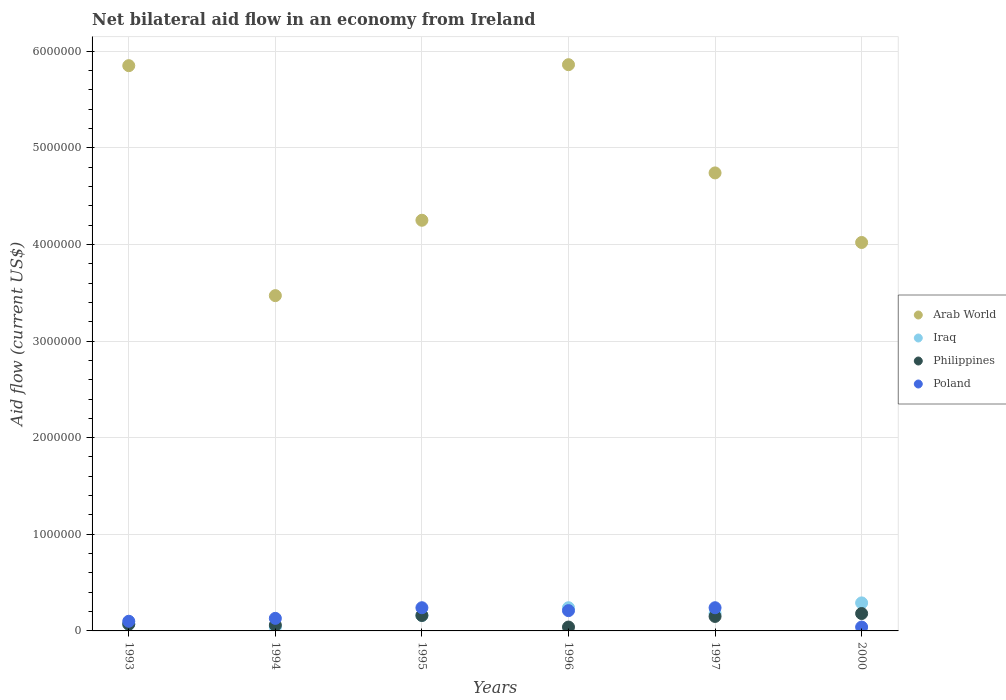Is the number of dotlines equal to the number of legend labels?
Make the answer very short. Yes. What is the net bilateral aid flow in Iraq in 1994?
Give a very brief answer. 4.00e+04. Across all years, what is the maximum net bilateral aid flow in Poland?
Make the answer very short. 2.40e+05. In which year was the net bilateral aid flow in Philippines maximum?
Offer a terse response. 2000. In which year was the net bilateral aid flow in Arab World minimum?
Ensure brevity in your answer.  1994. What is the total net bilateral aid flow in Poland in the graph?
Provide a succinct answer. 9.60e+05. What is the difference between the net bilateral aid flow in Poland in 1997 and that in 2000?
Your answer should be compact. 2.00e+05. What is the average net bilateral aid flow in Arab World per year?
Offer a very short reply. 4.70e+06. In the year 1995, what is the difference between the net bilateral aid flow in Arab World and net bilateral aid flow in Poland?
Your response must be concise. 4.01e+06. In how many years, is the net bilateral aid flow in Arab World greater than 1600000 US$?
Offer a terse response. 6. What is the ratio of the net bilateral aid flow in Poland in 1994 to that in 1996?
Offer a very short reply. 0.62. Is the difference between the net bilateral aid flow in Arab World in 1993 and 1996 greater than the difference between the net bilateral aid flow in Poland in 1993 and 1996?
Ensure brevity in your answer.  Yes. What is the difference between the highest and the lowest net bilateral aid flow in Arab World?
Give a very brief answer. 2.39e+06. Is the sum of the net bilateral aid flow in Philippines in 1993 and 1997 greater than the maximum net bilateral aid flow in Iraq across all years?
Offer a very short reply. No. Is it the case that in every year, the sum of the net bilateral aid flow in Iraq and net bilateral aid flow in Philippines  is greater than the sum of net bilateral aid flow in Poland and net bilateral aid flow in Arab World?
Your answer should be very brief. No. Is it the case that in every year, the sum of the net bilateral aid flow in Iraq and net bilateral aid flow in Poland  is greater than the net bilateral aid flow in Philippines?
Make the answer very short. Yes. Does the net bilateral aid flow in Philippines monotonically increase over the years?
Offer a very short reply. No. Is the net bilateral aid flow in Iraq strictly greater than the net bilateral aid flow in Poland over the years?
Provide a succinct answer. No. Is the net bilateral aid flow in Iraq strictly less than the net bilateral aid flow in Arab World over the years?
Keep it short and to the point. Yes. How many dotlines are there?
Ensure brevity in your answer.  4. What is the difference between two consecutive major ticks on the Y-axis?
Provide a succinct answer. 1.00e+06. Does the graph contain any zero values?
Ensure brevity in your answer.  No. How are the legend labels stacked?
Make the answer very short. Vertical. What is the title of the graph?
Your response must be concise. Net bilateral aid flow in an economy from Ireland. Does "Uganda" appear as one of the legend labels in the graph?
Ensure brevity in your answer.  No. What is the label or title of the X-axis?
Provide a short and direct response. Years. What is the Aid flow (current US$) in Arab World in 1993?
Your response must be concise. 5.85e+06. What is the Aid flow (current US$) of Poland in 1993?
Ensure brevity in your answer.  1.00e+05. What is the Aid flow (current US$) in Arab World in 1994?
Your response must be concise. 3.47e+06. What is the Aid flow (current US$) of Iraq in 1994?
Give a very brief answer. 4.00e+04. What is the Aid flow (current US$) in Philippines in 1994?
Ensure brevity in your answer.  6.00e+04. What is the Aid flow (current US$) in Poland in 1994?
Ensure brevity in your answer.  1.30e+05. What is the Aid flow (current US$) of Arab World in 1995?
Your response must be concise. 4.25e+06. What is the Aid flow (current US$) of Poland in 1995?
Your answer should be very brief. 2.40e+05. What is the Aid flow (current US$) of Arab World in 1996?
Give a very brief answer. 5.86e+06. What is the Aid flow (current US$) of Iraq in 1996?
Make the answer very short. 2.40e+05. What is the Aid flow (current US$) of Philippines in 1996?
Provide a short and direct response. 4.00e+04. What is the Aid flow (current US$) of Arab World in 1997?
Your answer should be compact. 4.74e+06. What is the Aid flow (current US$) of Iraq in 1997?
Provide a short and direct response. 1.80e+05. What is the Aid flow (current US$) in Philippines in 1997?
Provide a short and direct response. 1.50e+05. What is the Aid flow (current US$) of Arab World in 2000?
Give a very brief answer. 4.02e+06. What is the Aid flow (current US$) in Philippines in 2000?
Provide a short and direct response. 1.80e+05. What is the Aid flow (current US$) of Poland in 2000?
Keep it short and to the point. 4.00e+04. Across all years, what is the maximum Aid flow (current US$) in Arab World?
Give a very brief answer. 5.86e+06. Across all years, what is the maximum Aid flow (current US$) of Poland?
Your answer should be compact. 2.40e+05. Across all years, what is the minimum Aid flow (current US$) in Arab World?
Your response must be concise. 3.47e+06. Across all years, what is the minimum Aid flow (current US$) of Iraq?
Provide a succinct answer. 4.00e+04. Across all years, what is the minimum Aid flow (current US$) in Philippines?
Give a very brief answer. 4.00e+04. Across all years, what is the minimum Aid flow (current US$) of Poland?
Your response must be concise. 4.00e+04. What is the total Aid flow (current US$) of Arab World in the graph?
Provide a succinct answer. 2.82e+07. What is the total Aid flow (current US$) in Iraq in the graph?
Offer a terse response. 9.80e+05. What is the total Aid flow (current US$) of Poland in the graph?
Offer a very short reply. 9.60e+05. What is the difference between the Aid flow (current US$) of Arab World in 1993 and that in 1994?
Offer a terse response. 2.38e+06. What is the difference between the Aid flow (current US$) of Iraq in 1993 and that in 1994?
Provide a short and direct response. 3.00e+04. What is the difference between the Aid flow (current US$) of Arab World in 1993 and that in 1995?
Give a very brief answer. 1.60e+06. What is the difference between the Aid flow (current US$) in Poland in 1993 and that in 1995?
Your answer should be compact. -1.40e+05. What is the difference between the Aid flow (current US$) of Philippines in 1993 and that in 1996?
Give a very brief answer. 3.00e+04. What is the difference between the Aid flow (current US$) of Poland in 1993 and that in 1996?
Keep it short and to the point. -1.10e+05. What is the difference between the Aid flow (current US$) of Arab World in 1993 and that in 1997?
Give a very brief answer. 1.11e+06. What is the difference between the Aid flow (current US$) in Iraq in 1993 and that in 1997?
Provide a succinct answer. -1.10e+05. What is the difference between the Aid flow (current US$) in Philippines in 1993 and that in 1997?
Your answer should be compact. -8.00e+04. What is the difference between the Aid flow (current US$) in Arab World in 1993 and that in 2000?
Ensure brevity in your answer.  1.83e+06. What is the difference between the Aid flow (current US$) in Iraq in 1993 and that in 2000?
Your answer should be compact. -2.20e+05. What is the difference between the Aid flow (current US$) of Philippines in 1993 and that in 2000?
Provide a succinct answer. -1.10e+05. What is the difference between the Aid flow (current US$) of Poland in 1993 and that in 2000?
Offer a very short reply. 6.00e+04. What is the difference between the Aid flow (current US$) of Arab World in 1994 and that in 1995?
Offer a terse response. -7.80e+05. What is the difference between the Aid flow (current US$) of Iraq in 1994 and that in 1995?
Give a very brief answer. -1.20e+05. What is the difference between the Aid flow (current US$) of Poland in 1994 and that in 1995?
Offer a terse response. -1.10e+05. What is the difference between the Aid flow (current US$) of Arab World in 1994 and that in 1996?
Offer a very short reply. -2.39e+06. What is the difference between the Aid flow (current US$) in Iraq in 1994 and that in 1996?
Provide a succinct answer. -2.00e+05. What is the difference between the Aid flow (current US$) in Philippines in 1994 and that in 1996?
Give a very brief answer. 2.00e+04. What is the difference between the Aid flow (current US$) of Arab World in 1994 and that in 1997?
Offer a terse response. -1.27e+06. What is the difference between the Aid flow (current US$) in Philippines in 1994 and that in 1997?
Keep it short and to the point. -9.00e+04. What is the difference between the Aid flow (current US$) of Arab World in 1994 and that in 2000?
Your response must be concise. -5.50e+05. What is the difference between the Aid flow (current US$) of Iraq in 1994 and that in 2000?
Make the answer very short. -2.50e+05. What is the difference between the Aid flow (current US$) in Philippines in 1994 and that in 2000?
Your answer should be compact. -1.20e+05. What is the difference between the Aid flow (current US$) in Poland in 1994 and that in 2000?
Your answer should be very brief. 9.00e+04. What is the difference between the Aid flow (current US$) of Arab World in 1995 and that in 1996?
Keep it short and to the point. -1.61e+06. What is the difference between the Aid flow (current US$) of Philippines in 1995 and that in 1996?
Your response must be concise. 1.20e+05. What is the difference between the Aid flow (current US$) of Arab World in 1995 and that in 1997?
Your answer should be compact. -4.90e+05. What is the difference between the Aid flow (current US$) in Iraq in 1995 and that in 1997?
Offer a very short reply. -2.00e+04. What is the difference between the Aid flow (current US$) in Poland in 1995 and that in 1997?
Provide a succinct answer. 0. What is the difference between the Aid flow (current US$) of Arab World in 1995 and that in 2000?
Offer a very short reply. 2.30e+05. What is the difference between the Aid flow (current US$) of Philippines in 1995 and that in 2000?
Your answer should be compact. -2.00e+04. What is the difference between the Aid flow (current US$) of Arab World in 1996 and that in 1997?
Offer a terse response. 1.12e+06. What is the difference between the Aid flow (current US$) in Iraq in 1996 and that in 1997?
Offer a terse response. 6.00e+04. What is the difference between the Aid flow (current US$) in Philippines in 1996 and that in 1997?
Offer a very short reply. -1.10e+05. What is the difference between the Aid flow (current US$) in Poland in 1996 and that in 1997?
Provide a succinct answer. -3.00e+04. What is the difference between the Aid flow (current US$) of Arab World in 1996 and that in 2000?
Provide a short and direct response. 1.84e+06. What is the difference between the Aid flow (current US$) in Arab World in 1997 and that in 2000?
Keep it short and to the point. 7.20e+05. What is the difference between the Aid flow (current US$) of Iraq in 1997 and that in 2000?
Your response must be concise. -1.10e+05. What is the difference between the Aid flow (current US$) in Poland in 1997 and that in 2000?
Offer a terse response. 2.00e+05. What is the difference between the Aid flow (current US$) of Arab World in 1993 and the Aid flow (current US$) of Iraq in 1994?
Make the answer very short. 5.81e+06. What is the difference between the Aid flow (current US$) in Arab World in 1993 and the Aid flow (current US$) in Philippines in 1994?
Keep it short and to the point. 5.79e+06. What is the difference between the Aid flow (current US$) in Arab World in 1993 and the Aid flow (current US$) in Poland in 1994?
Make the answer very short. 5.72e+06. What is the difference between the Aid flow (current US$) in Iraq in 1993 and the Aid flow (current US$) in Philippines in 1994?
Offer a very short reply. 10000. What is the difference between the Aid flow (current US$) in Arab World in 1993 and the Aid flow (current US$) in Iraq in 1995?
Your answer should be very brief. 5.69e+06. What is the difference between the Aid flow (current US$) in Arab World in 1993 and the Aid flow (current US$) in Philippines in 1995?
Give a very brief answer. 5.69e+06. What is the difference between the Aid flow (current US$) of Arab World in 1993 and the Aid flow (current US$) of Poland in 1995?
Keep it short and to the point. 5.61e+06. What is the difference between the Aid flow (current US$) in Iraq in 1993 and the Aid flow (current US$) in Philippines in 1995?
Make the answer very short. -9.00e+04. What is the difference between the Aid flow (current US$) of Iraq in 1993 and the Aid flow (current US$) of Poland in 1995?
Make the answer very short. -1.70e+05. What is the difference between the Aid flow (current US$) of Philippines in 1993 and the Aid flow (current US$) of Poland in 1995?
Provide a succinct answer. -1.70e+05. What is the difference between the Aid flow (current US$) in Arab World in 1993 and the Aid flow (current US$) in Iraq in 1996?
Provide a short and direct response. 5.61e+06. What is the difference between the Aid flow (current US$) of Arab World in 1993 and the Aid flow (current US$) of Philippines in 1996?
Your response must be concise. 5.81e+06. What is the difference between the Aid flow (current US$) of Arab World in 1993 and the Aid flow (current US$) of Poland in 1996?
Offer a very short reply. 5.64e+06. What is the difference between the Aid flow (current US$) of Iraq in 1993 and the Aid flow (current US$) of Poland in 1996?
Provide a short and direct response. -1.40e+05. What is the difference between the Aid flow (current US$) of Philippines in 1993 and the Aid flow (current US$) of Poland in 1996?
Your response must be concise. -1.40e+05. What is the difference between the Aid flow (current US$) in Arab World in 1993 and the Aid flow (current US$) in Iraq in 1997?
Ensure brevity in your answer.  5.67e+06. What is the difference between the Aid flow (current US$) of Arab World in 1993 and the Aid flow (current US$) of Philippines in 1997?
Your answer should be very brief. 5.70e+06. What is the difference between the Aid flow (current US$) in Arab World in 1993 and the Aid flow (current US$) in Poland in 1997?
Your answer should be very brief. 5.61e+06. What is the difference between the Aid flow (current US$) in Iraq in 1993 and the Aid flow (current US$) in Philippines in 1997?
Ensure brevity in your answer.  -8.00e+04. What is the difference between the Aid flow (current US$) in Philippines in 1993 and the Aid flow (current US$) in Poland in 1997?
Your response must be concise. -1.70e+05. What is the difference between the Aid flow (current US$) of Arab World in 1993 and the Aid flow (current US$) of Iraq in 2000?
Provide a succinct answer. 5.56e+06. What is the difference between the Aid flow (current US$) in Arab World in 1993 and the Aid flow (current US$) in Philippines in 2000?
Offer a terse response. 5.67e+06. What is the difference between the Aid flow (current US$) in Arab World in 1993 and the Aid flow (current US$) in Poland in 2000?
Your answer should be compact. 5.81e+06. What is the difference between the Aid flow (current US$) of Philippines in 1993 and the Aid flow (current US$) of Poland in 2000?
Make the answer very short. 3.00e+04. What is the difference between the Aid flow (current US$) of Arab World in 1994 and the Aid flow (current US$) of Iraq in 1995?
Give a very brief answer. 3.31e+06. What is the difference between the Aid flow (current US$) in Arab World in 1994 and the Aid flow (current US$) in Philippines in 1995?
Your answer should be very brief. 3.31e+06. What is the difference between the Aid flow (current US$) of Arab World in 1994 and the Aid flow (current US$) of Poland in 1995?
Keep it short and to the point. 3.23e+06. What is the difference between the Aid flow (current US$) in Iraq in 1994 and the Aid flow (current US$) in Philippines in 1995?
Keep it short and to the point. -1.20e+05. What is the difference between the Aid flow (current US$) of Iraq in 1994 and the Aid flow (current US$) of Poland in 1995?
Ensure brevity in your answer.  -2.00e+05. What is the difference between the Aid flow (current US$) of Philippines in 1994 and the Aid flow (current US$) of Poland in 1995?
Keep it short and to the point. -1.80e+05. What is the difference between the Aid flow (current US$) in Arab World in 1994 and the Aid flow (current US$) in Iraq in 1996?
Give a very brief answer. 3.23e+06. What is the difference between the Aid flow (current US$) in Arab World in 1994 and the Aid flow (current US$) in Philippines in 1996?
Ensure brevity in your answer.  3.43e+06. What is the difference between the Aid flow (current US$) of Arab World in 1994 and the Aid flow (current US$) of Poland in 1996?
Offer a terse response. 3.26e+06. What is the difference between the Aid flow (current US$) in Arab World in 1994 and the Aid flow (current US$) in Iraq in 1997?
Provide a succinct answer. 3.29e+06. What is the difference between the Aid flow (current US$) in Arab World in 1994 and the Aid flow (current US$) in Philippines in 1997?
Your answer should be very brief. 3.32e+06. What is the difference between the Aid flow (current US$) of Arab World in 1994 and the Aid flow (current US$) of Poland in 1997?
Provide a succinct answer. 3.23e+06. What is the difference between the Aid flow (current US$) of Iraq in 1994 and the Aid flow (current US$) of Poland in 1997?
Ensure brevity in your answer.  -2.00e+05. What is the difference between the Aid flow (current US$) of Philippines in 1994 and the Aid flow (current US$) of Poland in 1997?
Keep it short and to the point. -1.80e+05. What is the difference between the Aid flow (current US$) of Arab World in 1994 and the Aid flow (current US$) of Iraq in 2000?
Your response must be concise. 3.18e+06. What is the difference between the Aid flow (current US$) in Arab World in 1994 and the Aid flow (current US$) in Philippines in 2000?
Keep it short and to the point. 3.29e+06. What is the difference between the Aid flow (current US$) of Arab World in 1994 and the Aid flow (current US$) of Poland in 2000?
Your answer should be compact. 3.43e+06. What is the difference between the Aid flow (current US$) in Iraq in 1994 and the Aid flow (current US$) in Poland in 2000?
Your answer should be compact. 0. What is the difference between the Aid flow (current US$) in Philippines in 1994 and the Aid flow (current US$) in Poland in 2000?
Your answer should be very brief. 2.00e+04. What is the difference between the Aid flow (current US$) in Arab World in 1995 and the Aid flow (current US$) in Iraq in 1996?
Keep it short and to the point. 4.01e+06. What is the difference between the Aid flow (current US$) of Arab World in 1995 and the Aid flow (current US$) of Philippines in 1996?
Offer a terse response. 4.21e+06. What is the difference between the Aid flow (current US$) of Arab World in 1995 and the Aid flow (current US$) of Poland in 1996?
Your response must be concise. 4.04e+06. What is the difference between the Aid flow (current US$) of Iraq in 1995 and the Aid flow (current US$) of Philippines in 1996?
Keep it short and to the point. 1.20e+05. What is the difference between the Aid flow (current US$) in Iraq in 1995 and the Aid flow (current US$) in Poland in 1996?
Ensure brevity in your answer.  -5.00e+04. What is the difference between the Aid flow (current US$) in Arab World in 1995 and the Aid flow (current US$) in Iraq in 1997?
Provide a short and direct response. 4.07e+06. What is the difference between the Aid flow (current US$) of Arab World in 1995 and the Aid flow (current US$) of Philippines in 1997?
Keep it short and to the point. 4.10e+06. What is the difference between the Aid flow (current US$) in Arab World in 1995 and the Aid flow (current US$) in Poland in 1997?
Your answer should be compact. 4.01e+06. What is the difference between the Aid flow (current US$) of Iraq in 1995 and the Aid flow (current US$) of Philippines in 1997?
Your response must be concise. 10000. What is the difference between the Aid flow (current US$) in Iraq in 1995 and the Aid flow (current US$) in Poland in 1997?
Offer a very short reply. -8.00e+04. What is the difference between the Aid flow (current US$) in Arab World in 1995 and the Aid flow (current US$) in Iraq in 2000?
Ensure brevity in your answer.  3.96e+06. What is the difference between the Aid flow (current US$) in Arab World in 1995 and the Aid flow (current US$) in Philippines in 2000?
Your answer should be very brief. 4.07e+06. What is the difference between the Aid flow (current US$) in Arab World in 1995 and the Aid flow (current US$) in Poland in 2000?
Offer a very short reply. 4.21e+06. What is the difference between the Aid flow (current US$) of Iraq in 1995 and the Aid flow (current US$) of Philippines in 2000?
Ensure brevity in your answer.  -2.00e+04. What is the difference between the Aid flow (current US$) of Iraq in 1995 and the Aid flow (current US$) of Poland in 2000?
Provide a short and direct response. 1.20e+05. What is the difference between the Aid flow (current US$) in Philippines in 1995 and the Aid flow (current US$) in Poland in 2000?
Ensure brevity in your answer.  1.20e+05. What is the difference between the Aid flow (current US$) of Arab World in 1996 and the Aid flow (current US$) of Iraq in 1997?
Keep it short and to the point. 5.68e+06. What is the difference between the Aid flow (current US$) in Arab World in 1996 and the Aid flow (current US$) in Philippines in 1997?
Your answer should be very brief. 5.71e+06. What is the difference between the Aid flow (current US$) in Arab World in 1996 and the Aid flow (current US$) in Poland in 1997?
Give a very brief answer. 5.62e+06. What is the difference between the Aid flow (current US$) in Iraq in 1996 and the Aid flow (current US$) in Philippines in 1997?
Offer a terse response. 9.00e+04. What is the difference between the Aid flow (current US$) in Arab World in 1996 and the Aid flow (current US$) in Iraq in 2000?
Your answer should be very brief. 5.57e+06. What is the difference between the Aid flow (current US$) of Arab World in 1996 and the Aid flow (current US$) of Philippines in 2000?
Your response must be concise. 5.68e+06. What is the difference between the Aid flow (current US$) of Arab World in 1996 and the Aid flow (current US$) of Poland in 2000?
Offer a terse response. 5.82e+06. What is the difference between the Aid flow (current US$) of Iraq in 1996 and the Aid flow (current US$) of Philippines in 2000?
Your response must be concise. 6.00e+04. What is the difference between the Aid flow (current US$) in Arab World in 1997 and the Aid flow (current US$) in Iraq in 2000?
Your answer should be compact. 4.45e+06. What is the difference between the Aid flow (current US$) of Arab World in 1997 and the Aid flow (current US$) of Philippines in 2000?
Keep it short and to the point. 4.56e+06. What is the difference between the Aid flow (current US$) in Arab World in 1997 and the Aid flow (current US$) in Poland in 2000?
Keep it short and to the point. 4.70e+06. What is the difference between the Aid flow (current US$) of Iraq in 1997 and the Aid flow (current US$) of Poland in 2000?
Your answer should be very brief. 1.40e+05. What is the difference between the Aid flow (current US$) of Philippines in 1997 and the Aid flow (current US$) of Poland in 2000?
Your response must be concise. 1.10e+05. What is the average Aid flow (current US$) of Arab World per year?
Your response must be concise. 4.70e+06. What is the average Aid flow (current US$) of Iraq per year?
Your response must be concise. 1.63e+05. What is the average Aid flow (current US$) in Philippines per year?
Ensure brevity in your answer.  1.10e+05. In the year 1993, what is the difference between the Aid flow (current US$) of Arab World and Aid flow (current US$) of Iraq?
Your response must be concise. 5.78e+06. In the year 1993, what is the difference between the Aid flow (current US$) of Arab World and Aid flow (current US$) of Philippines?
Ensure brevity in your answer.  5.78e+06. In the year 1993, what is the difference between the Aid flow (current US$) in Arab World and Aid flow (current US$) in Poland?
Give a very brief answer. 5.75e+06. In the year 1993, what is the difference between the Aid flow (current US$) in Iraq and Aid flow (current US$) in Philippines?
Offer a very short reply. 0. In the year 1993, what is the difference between the Aid flow (current US$) in Iraq and Aid flow (current US$) in Poland?
Ensure brevity in your answer.  -3.00e+04. In the year 1994, what is the difference between the Aid flow (current US$) in Arab World and Aid flow (current US$) in Iraq?
Your answer should be very brief. 3.43e+06. In the year 1994, what is the difference between the Aid flow (current US$) in Arab World and Aid flow (current US$) in Philippines?
Offer a terse response. 3.41e+06. In the year 1994, what is the difference between the Aid flow (current US$) of Arab World and Aid flow (current US$) of Poland?
Keep it short and to the point. 3.34e+06. In the year 1994, what is the difference between the Aid flow (current US$) of Iraq and Aid flow (current US$) of Philippines?
Make the answer very short. -2.00e+04. In the year 1995, what is the difference between the Aid flow (current US$) of Arab World and Aid flow (current US$) of Iraq?
Ensure brevity in your answer.  4.09e+06. In the year 1995, what is the difference between the Aid flow (current US$) of Arab World and Aid flow (current US$) of Philippines?
Your answer should be compact. 4.09e+06. In the year 1995, what is the difference between the Aid flow (current US$) of Arab World and Aid flow (current US$) of Poland?
Offer a terse response. 4.01e+06. In the year 1995, what is the difference between the Aid flow (current US$) of Philippines and Aid flow (current US$) of Poland?
Give a very brief answer. -8.00e+04. In the year 1996, what is the difference between the Aid flow (current US$) of Arab World and Aid flow (current US$) of Iraq?
Keep it short and to the point. 5.62e+06. In the year 1996, what is the difference between the Aid flow (current US$) in Arab World and Aid flow (current US$) in Philippines?
Give a very brief answer. 5.82e+06. In the year 1996, what is the difference between the Aid flow (current US$) of Arab World and Aid flow (current US$) of Poland?
Give a very brief answer. 5.65e+06. In the year 1996, what is the difference between the Aid flow (current US$) in Iraq and Aid flow (current US$) in Philippines?
Provide a succinct answer. 2.00e+05. In the year 1996, what is the difference between the Aid flow (current US$) of Iraq and Aid flow (current US$) of Poland?
Provide a short and direct response. 3.00e+04. In the year 1997, what is the difference between the Aid flow (current US$) in Arab World and Aid flow (current US$) in Iraq?
Offer a very short reply. 4.56e+06. In the year 1997, what is the difference between the Aid flow (current US$) of Arab World and Aid flow (current US$) of Philippines?
Make the answer very short. 4.59e+06. In the year 1997, what is the difference between the Aid flow (current US$) in Arab World and Aid flow (current US$) in Poland?
Offer a very short reply. 4.50e+06. In the year 1997, what is the difference between the Aid flow (current US$) in Iraq and Aid flow (current US$) in Poland?
Offer a very short reply. -6.00e+04. In the year 2000, what is the difference between the Aid flow (current US$) in Arab World and Aid flow (current US$) in Iraq?
Your response must be concise. 3.73e+06. In the year 2000, what is the difference between the Aid flow (current US$) in Arab World and Aid flow (current US$) in Philippines?
Your answer should be very brief. 3.84e+06. In the year 2000, what is the difference between the Aid flow (current US$) of Arab World and Aid flow (current US$) of Poland?
Keep it short and to the point. 3.98e+06. In the year 2000, what is the difference between the Aid flow (current US$) in Iraq and Aid flow (current US$) in Philippines?
Your answer should be very brief. 1.10e+05. In the year 2000, what is the difference between the Aid flow (current US$) of Iraq and Aid flow (current US$) of Poland?
Ensure brevity in your answer.  2.50e+05. What is the ratio of the Aid flow (current US$) in Arab World in 1993 to that in 1994?
Make the answer very short. 1.69. What is the ratio of the Aid flow (current US$) in Poland in 1993 to that in 1994?
Your answer should be very brief. 0.77. What is the ratio of the Aid flow (current US$) in Arab World in 1993 to that in 1995?
Ensure brevity in your answer.  1.38. What is the ratio of the Aid flow (current US$) of Iraq in 1993 to that in 1995?
Offer a very short reply. 0.44. What is the ratio of the Aid flow (current US$) in Philippines in 1993 to that in 1995?
Provide a short and direct response. 0.44. What is the ratio of the Aid flow (current US$) in Poland in 1993 to that in 1995?
Offer a very short reply. 0.42. What is the ratio of the Aid flow (current US$) of Arab World in 1993 to that in 1996?
Your answer should be compact. 1. What is the ratio of the Aid flow (current US$) of Iraq in 1993 to that in 1996?
Your answer should be compact. 0.29. What is the ratio of the Aid flow (current US$) of Philippines in 1993 to that in 1996?
Ensure brevity in your answer.  1.75. What is the ratio of the Aid flow (current US$) of Poland in 1993 to that in 1996?
Your response must be concise. 0.48. What is the ratio of the Aid flow (current US$) of Arab World in 1993 to that in 1997?
Keep it short and to the point. 1.23. What is the ratio of the Aid flow (current US$) in Iraq in 1993 to that in 1997?
Ensure brevity in your answer.  0.39. What is the ratio of the Aid flow (current US$) of Philippines in 1993 to that in 1997?
Your answer should be very brief. 0.47. What is the ratio of the Aid flow (current US$) in Poland in 1993 to that in 1997?
Your answer should be compact. 0.42. What is the ratio of the Aid flow (current US$) in Arab World in 1993 to that in 2000?
Provide a short and direct response. 1.46. What is the ratio of the Aid flow (current US$) of Iraq in 1993 to that in 2000?
Ensure brevity in your answer.  0.24. What is the ratio of the Aid flow (current US$) in Philippines in 1993 to that in 2000?
Provide a succinct answer. 0.39. What is the ratio of the Aid flow (current US$) of Poland in 1993 to that in 2000?
Provide a succinct answer. 2.5. What is the ratio of the Aid flow (current US$) of Arab World in 1994 to that in 1995?
Ensure brevity in your answer.  0.82. What is the ratio of the Aid flow (current US$) of Iraq in 1994 to that in 1995?
Provide a short and direct response. 0.25. What is the ratio of the Aid flow (current US$) in Poland in 1994 to that in 1995?
Your answer should be compact. 0.54. What is the ratio of the Aid flow (current US$) of Arab World in 1994 to that in 1996?
Your response must be concise. 0.59. What is the ratio of the Aid flow (current US$) of Iraq in 1994 to that in 1996?
Offer a terse response. 0.17. What is the ratio of the Aid flow (current US$) of Poland in 1994 to that in 1996?
Give a very brief answer. 0.62. What is the ratio of the Aid flow (current US$) of Arab World in 1994 to that in 1997?
Provide a short and direct response. 0.73. What is the ratio of the Aid flow (current US$) of Iraq in 1994 to that in 1997?
Give a very brief answer. 0.22. What is the ratio of the Aid flow (current US$) of Philippines in 1994 to that in 1997?
Your response must be concise. 0.4. What is the ratio of the Aid flow (current US$) in Poland in 1994 to that in 1997?
Offer a terse response. 0.54. What is the ratio of the Aid flow (current US$) in Arab World in 1994 to that in 2000?
Ensure brevity in your answer.  0.86. What is the ratio of the Aid flow (current US$) of Iraq in 1994 to that in 2000?
Make the answer very short. 0.14. What is the ratio of the Aid flow (current US$) of Philippines in 1994 to that in 2000?
Provide a succinct answer. 0.33. What is the ratio of the Aid flow (current US$) in Poland in 1994 to that in 2000?
Ensure brevity in your answer.  3.25. What is the ratio of the Aid flow (current US$) in Arab World in 1995 to that in 1996?
Give a very brief answer. 0.73. What is the ratio of the Aid flow (current US$) in Iraq in 1995 to that in 1996?
Make the answer very short. 0.67. What is the ratio of the Aid flow (current US$) of Poland in 1995 to that in 1996?
Offer a very short reply. 1.14. What is the ratio of the Aid flow (current US$) of Arab World in 1995 to that in 1997?
Provide a succinct answer. 0.9. What is the ratio of the Aid flow (current US$) in Philippines in 1995 to that in 1997?
Provide a short and direct response. 1.07. What is the ratio of the Aid flow (current US$) in Arab World in 1995 to that in 2000?
Keep it short and to the point. 1.06. What is the ratio of the Aid flow (current US$) in Iraq in 1995 to that in 2000?
Keep it short and to the point. 0.55. What is the ratio of the Aid flow (current US$) in Arab World in 1996 to that in 1997?
Provide a short and direct response. 1.24. What is the ratio of the Aid flow (current US$) in Iraq in 1996 to that in 1997?
Your answer should be very brief. 1.33. What is the ratio of the Aid flow (current US$) in Philippines in 1996 to that in 1997?
Keep it short and to the point. 0.27. What is the ratio of the Aid flow (current US$) of Arab World in 1996 to that in 2000?
Make the answer very short. 1.46. What is the ratio of the Aid flow (current US$) of Iraq in 1996 to that in 2000?
Give a very brief answer. 0.83. What is the ratio of the Aid flow (current US$) of Philippines in 1996 to that in 2000?
Your response must be concise. 0.22. What is the ratio of the Aid flow (current US$) in Poland in 1996 to that in 2000?
Give a very brief answer. 5.25. What is the ratio of the Aid flow (current US$) of Arab World in 1997 to that in 2000?
Provide a succinct answer. 1.18. What is the ratio of the Aid flow (current US$) of Iraq in 1997 to that in 2000?
Your answer should be very brief. 0.62. What is the ratio of the Aid flow (current US$) in Poland in 1997 to that in 2000?
Keep it short and to the point. 6. What is the difference between the highest and the second highest Aid flow (current US$) of Arab World?
Offer a terse response. 10000. What is the difference between the highest and the second highest Aid flow (current US$) of Philippines?
Your answer should be very brief. 2.00e+04. What is the difference between the highest and the lowest Aid flow (current US$) in Arab World?
Keep it short and to the point. 2.39e+06. 